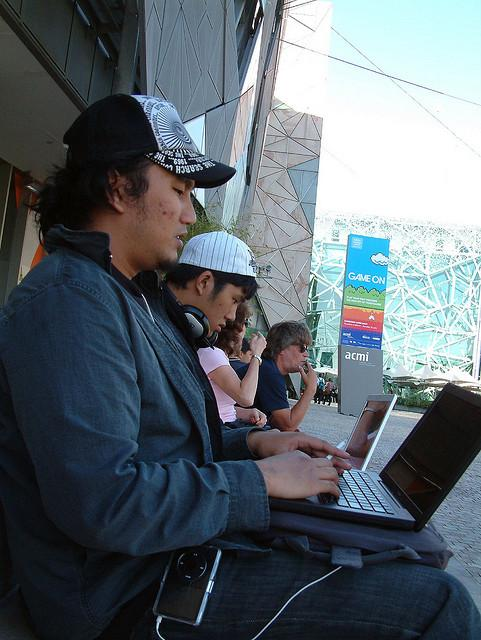What race is the man closest to the camera? Please explain your reasoning. asian. The man has black hair. 